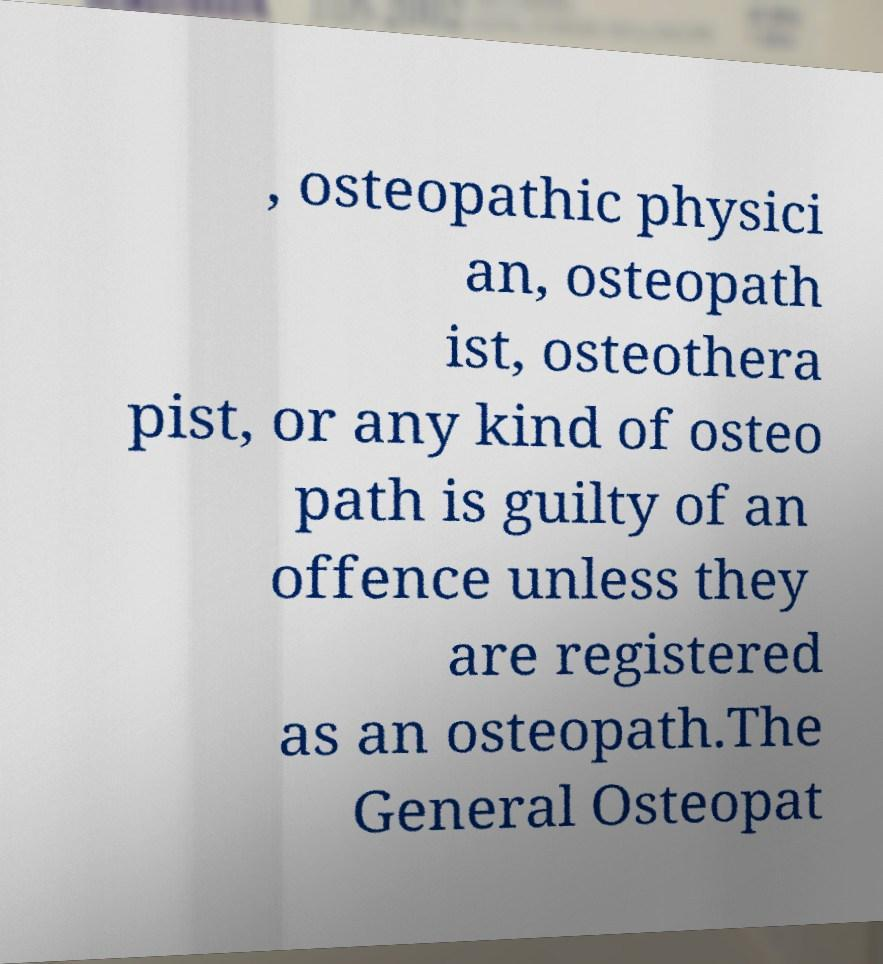Please read and relay the text visible in this image. What does it say? , osteopathic physici an, osteopath ist, osteothera pist, or any kind of osteo path is guilty of an offence unless they are registered as an osteopath.The General Osteopat 